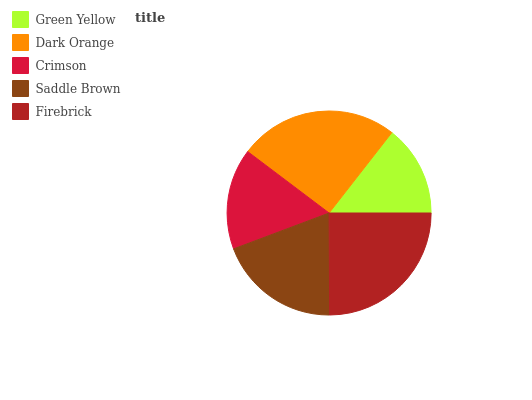Is Green Yellow the minimum?
Answer yes or no. Yes. Is Dark Orange the maximum?
Answer yes or no. Yes. Is Crimson the minimum?
Answer yes or no. No. Is Crimson the maximum?
Answer yes or no. No. Is Dark Orange greater than Crimson?
Answer yes or no. Yes. Is Crimson less than Dark Orange?
Answer yes or no. Yes. Is Crimson greater than Dark Orange?
Answer yes or no. No. Is Dark Orange less than Crimson?
Answer yes or no. No. Is Saddle Brown the high median?
Answer yes or no. Yes. Is Saddle Brown the low median?
Answer yes or no. Yes. Is Firebrick the high median?
Answer yes or no. No. Is Firebrick the low median?
Answer yes or no. No. 